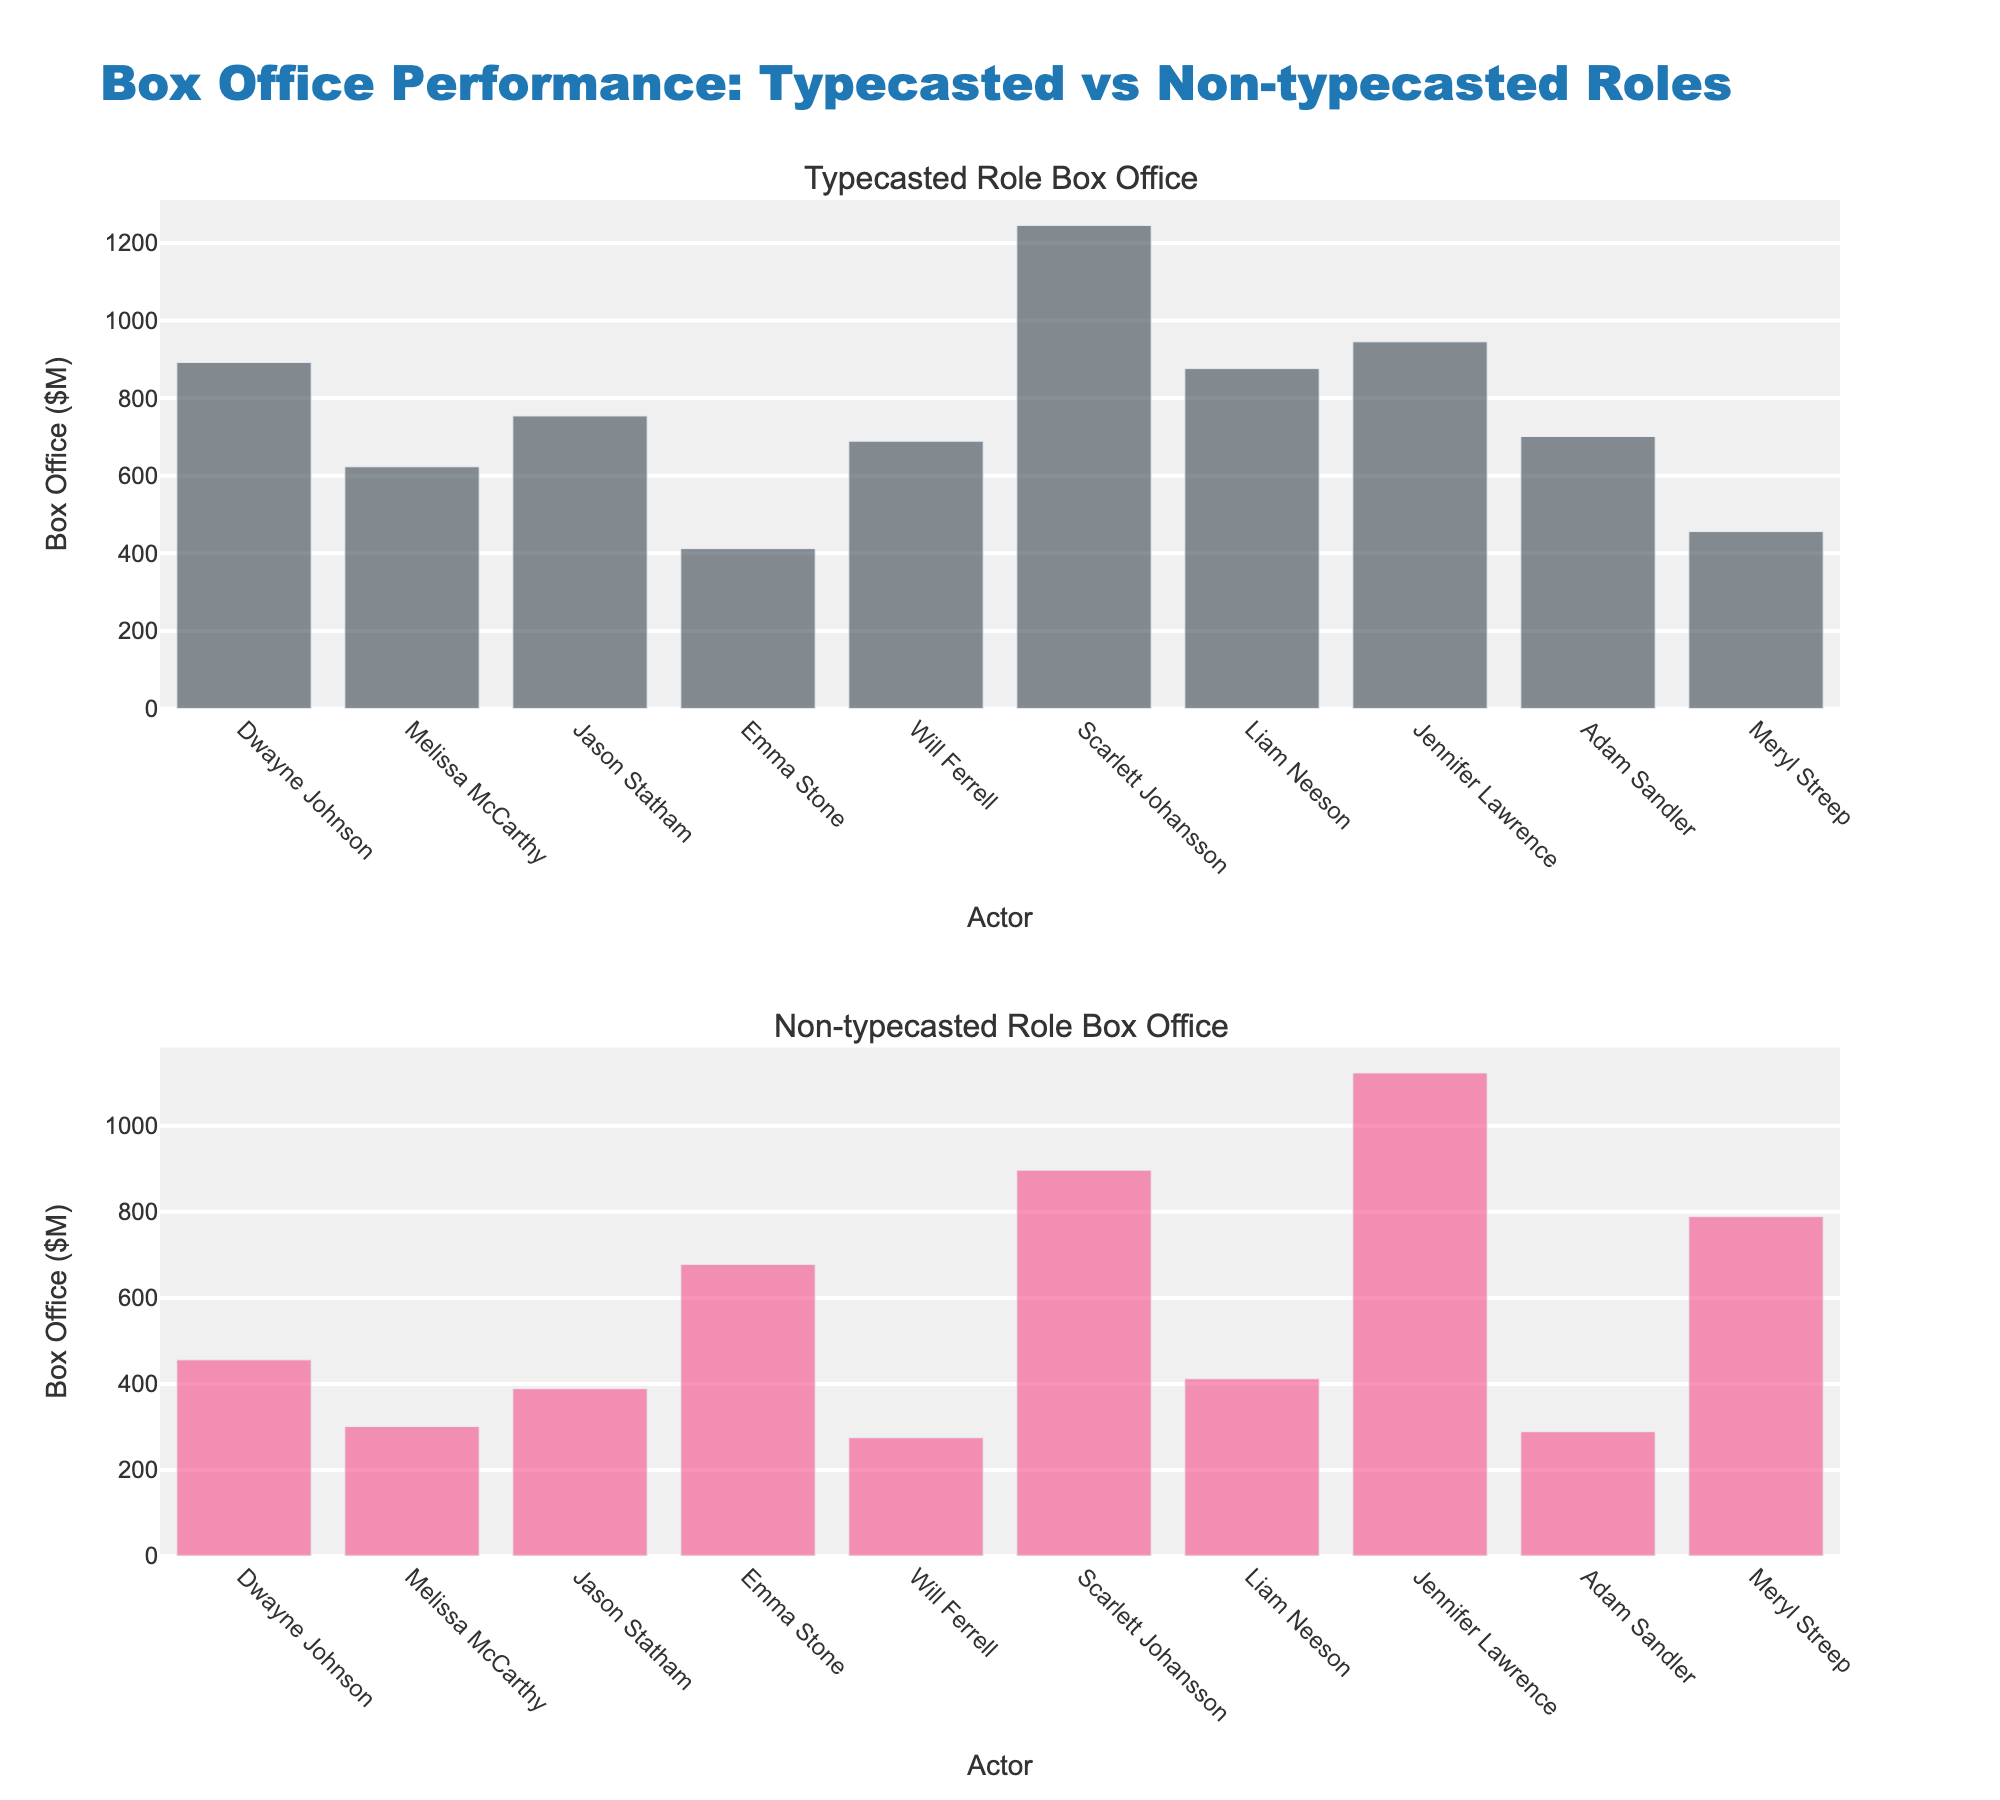What's the title of the figure? The title is displayed at the top of the figure.
Answer: Box Office Performance: Typecasted vs Non-typecasted Roles How many actors are represented in the figure? By counting the 'Actor' labels along the x-axis, we see that there are 10 actors represented.
Answer: 10 Which actor has the highest box office earnings in typecasted roles? Look at the height of the bars in the first subplot and identify the tallest one.
Answer: Scarlett Johansson Which actor has the highest box office earnings in non-typecasted roles? Look at the height of the bars in the second subplot and identify the tallest one.
Answer: Jennifer Lawrence What is the difference in typecasted role box office earnings between Dwayne Johnson and Jason Statham? Subtract Jason Statham’s earnings from Dwayne Johnson’s earnings in the first subplot: 892 - 754.
Answer: 138 Who is more successful in non-typecasted roles: Emma Stone or Meryl Streep? Compare the heights of their bars in the second subplot.
Answer: Meryl Streep What is the combined box office revenue for typecasted roles for Scarlett Johansson and Liam Neeson? Add their box office earnings from the first subplot: 1245 + 876.
Answer: 2121 Which actor has a greater discrepancy between typecasted and non-typecasted roles, Will Ferrell or Adam Sandler? Calculate the difference for each and compare: Will Ferrell: 689 - 275 = 414, Adam Sandler: 701 - 289 = 412.
Answer: Will Ferrell Which subplot shows the higher overall box office earnings? Sum the box office earnings for all actors in each subplot and compare.
Answer: Typecasted Role Box Office How do the box office earnings for Jennifer Lawrence in non-typecasted roles compare to her earnings in typecasted roles? Compare the height of Jennifer Lawrence's bars in both subplots.
Answer: Higher in non-typecasted roles 